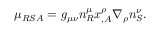Convert formula to latex. <formula><loc_0><loc_0><loc_500><loc_500>\mu _ { R S A } = g _ { \mu \nu } n _ { R } ^ { \mu } x _ { , A } ^ { \rho } \nabla _ { \rho } n _ { S } ^ { \nu } .</formula> 